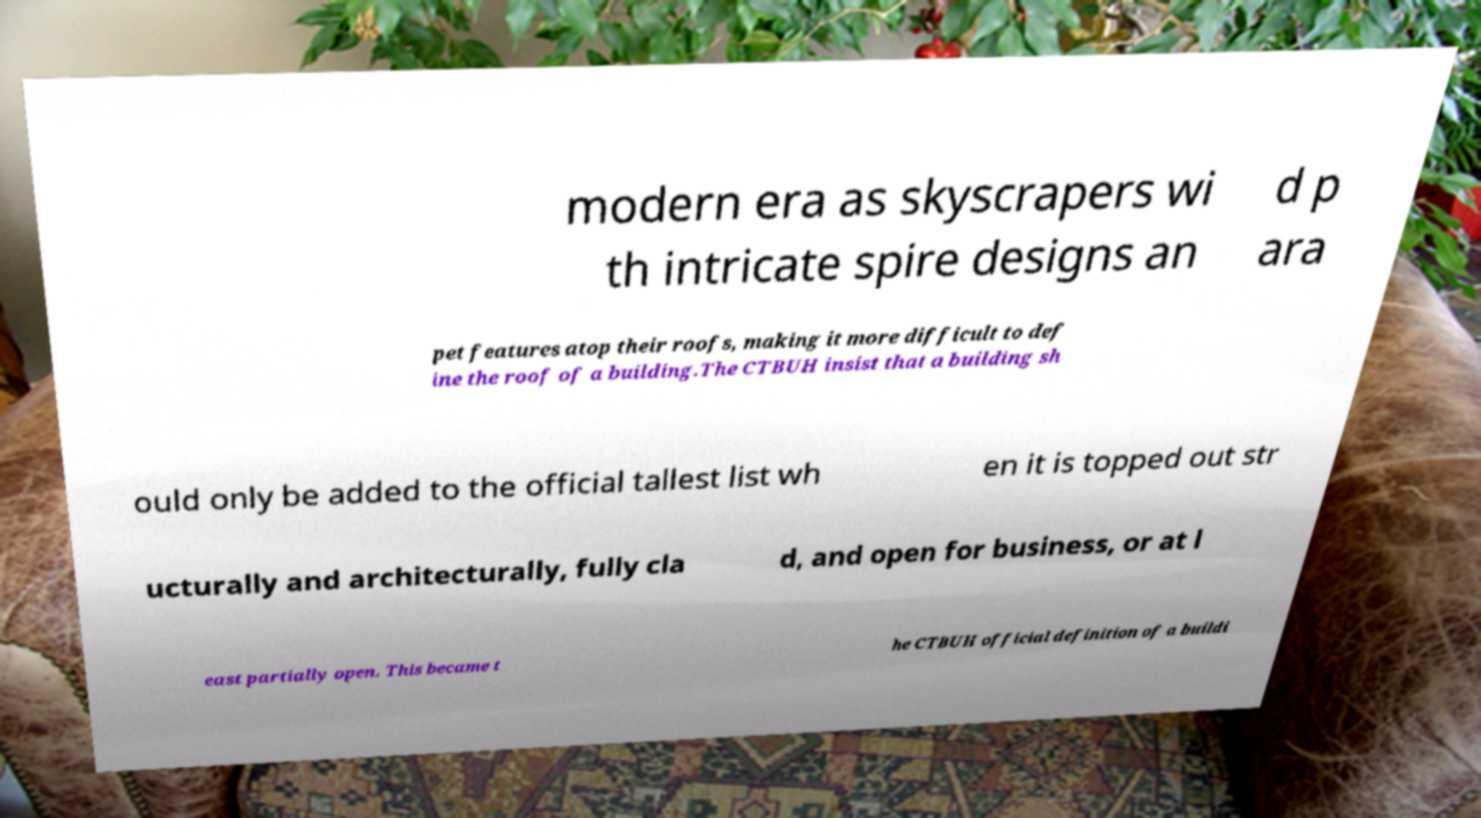There's text embedded in this image that I need extracted. Can you transcribe it verbatim? modern era as skyscrapers wi th intricate spire designs an d p ara pet features atop their roofs, making it more difficult to def ine the roof of a building.The CTBUH insist that a building sh ould only be added to the official tallest list wh en it is topped out str ucturally and architecturally, fully cla d, and open for business, or at l east partially open. This became t he CTBUH official definition of a buildi 